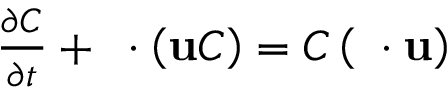<formula> <loc_0><loc_0><loc_500><loc_500>\begin{array} { r } { \frac { \partial C } { \partial t } + \nabla \cdot \left ( u C \right ) = C \left ( \nabla \cdot u \right ) } \end{array}</formula> 